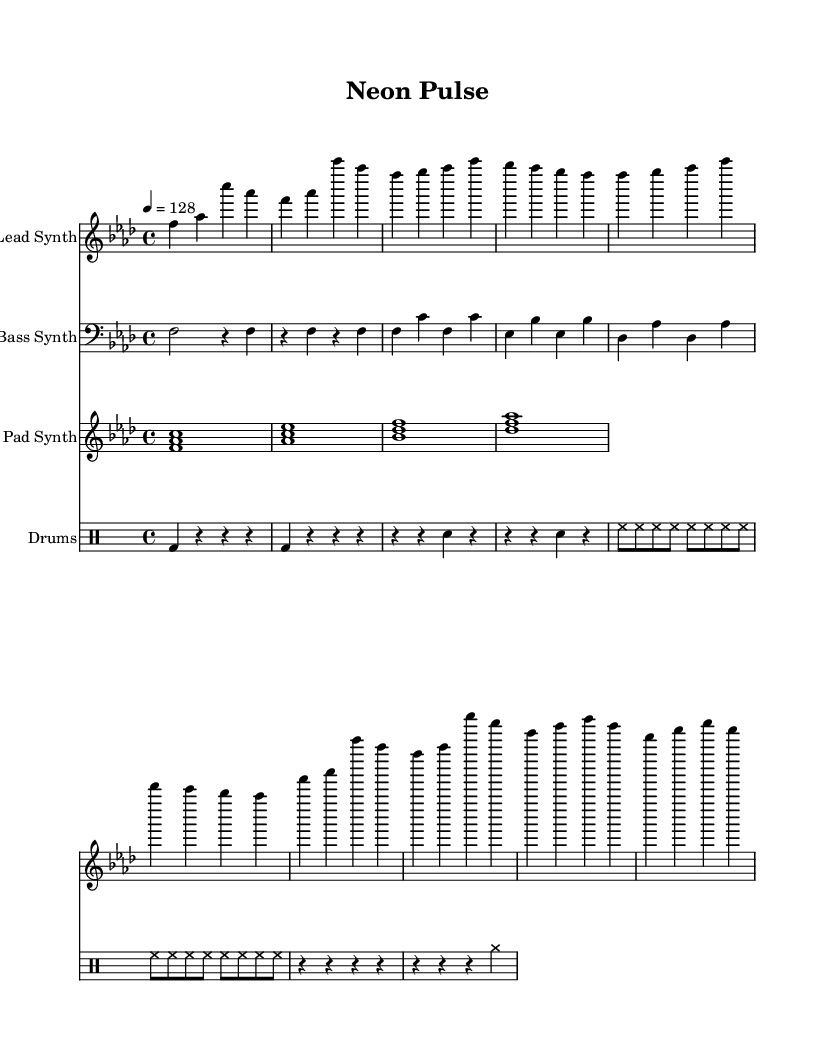What is the key signature of this music? The key signature is F minor, which has four flats: B flat, E flat, A flat, and D flat. This is determined by looking for the key signature indicated at the beginning of the score.
Answer: F minor What is the time signature of this music? The time signature is 4/4, indicating that there are four beats per measure and the quarter note receives one beat. This is noted at the beginning of the score right after the key signature.
Answer: 4/4 What is the tempo of this piece? The tempo marking indicates a speed of 128 beats per minute, shown by the instruction "4 = 128" in the score. This tells us to interpret the quarter note at that specific speed.
Answer: 128 How many measures are in the lead synth part? By counting the distinct measures in the lead synth clef section, we find there are a total of 12 measures. Each group of notes is separated by a bar line, allowing for clear counting.
Answer: 12 What instrument is represented by the lowest staff? The lowest staff in the score is labeled for the bass synth, as indicated at the beginning of that staff with the designation "Bass Synth." It's important to look at the instrument name indicators in each staff.
Answer: Bass Synth Which section of the piece contains a build-up to a drop? The "Drop" section in the lead synth part is where the intensity increases, identified by a change in rhythm and dynamics compared to the preceding sections, emphasizing a high-energy moment in the music.
Answer: Drop What rhythmic pattern is used for the drum part? The drum part exhibits a repetitive pattern starting with the bass drum followed by snare and hi-hat sounds, which provides the foundational beat typically found in dance music genres, and is structured to enhance the rhythmic drive.
Answer: Repetitive pattern 